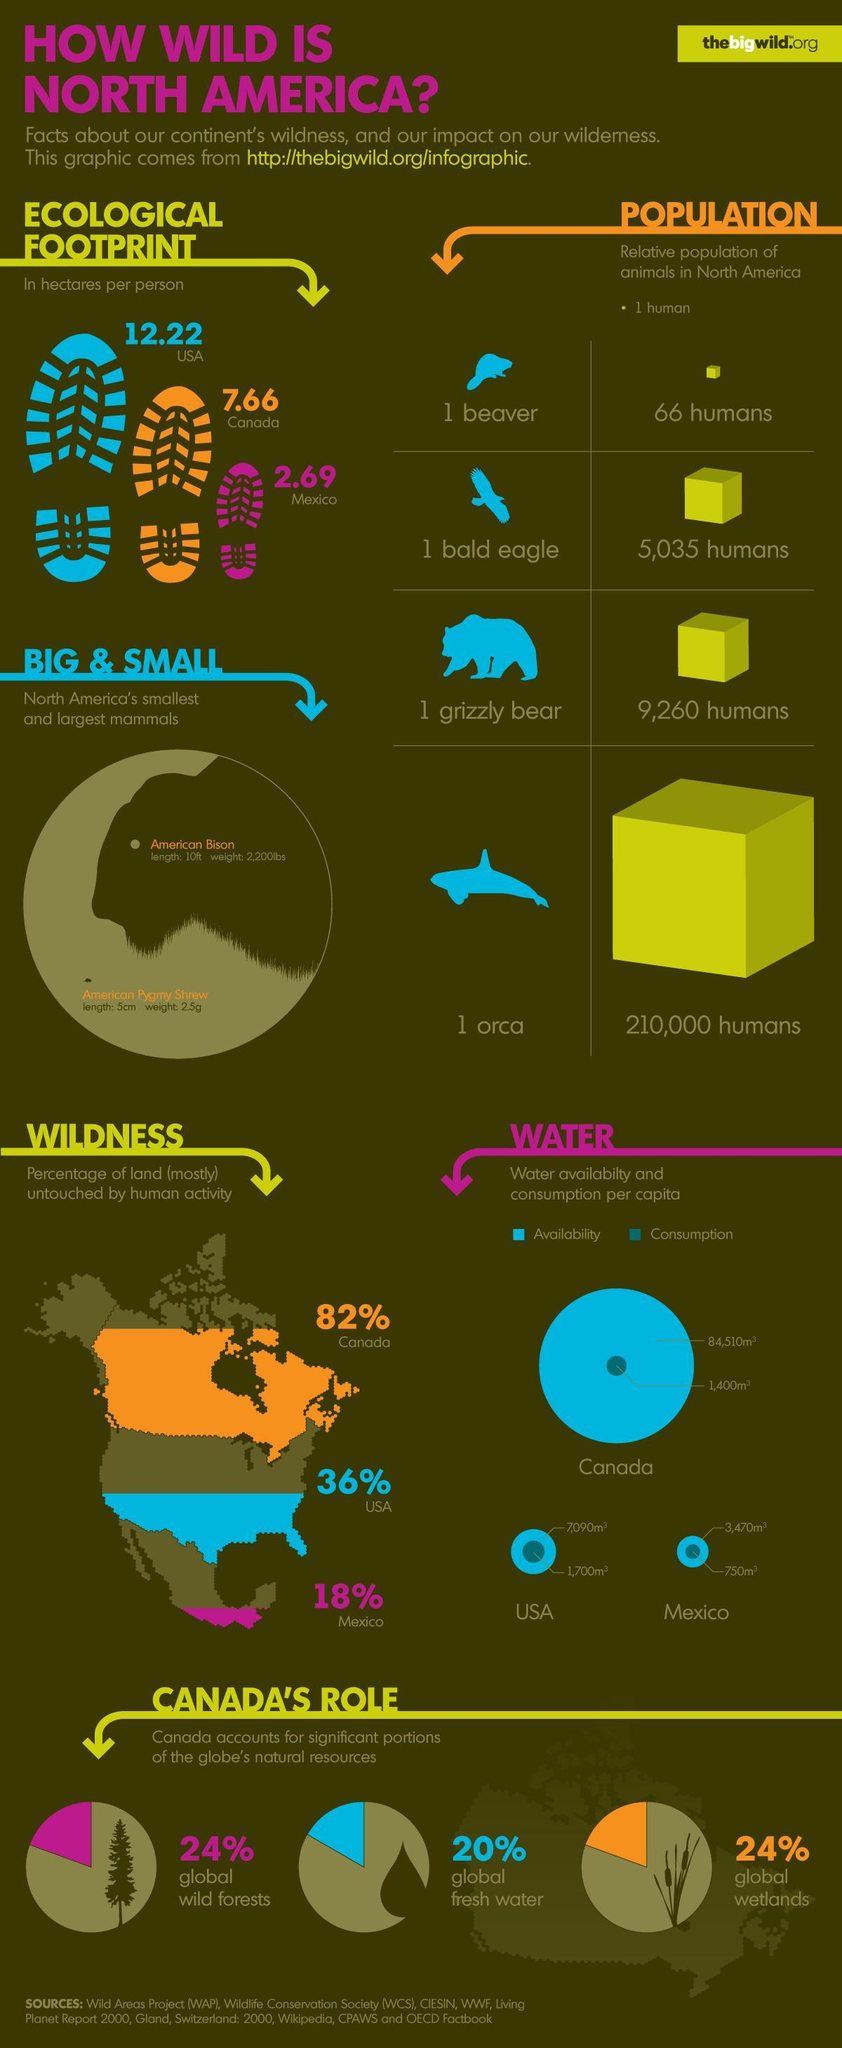What is the water availability per capita in USA
Answer the question with a short phrase. 7,090m3 What is the water availability per capita in Canada 84,510m3 What is the water consumption per capita in Mexico 750m3 what is the total ecological footprint in hectares per person in USA and Canada 19.88 Which is the smallest mammal in North America American Pygmy Shrew Which is the largest mammal in North America American Bison What are the global natural resources categorized in Canada's role wild forests, fresh water, wetlands 